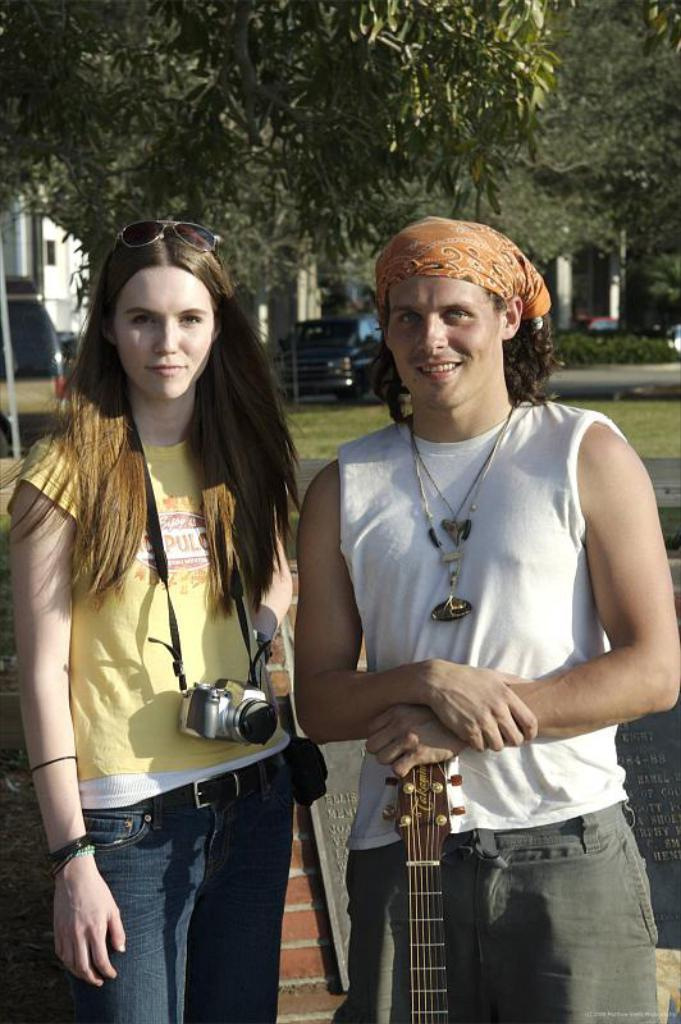What is the person on the right side of the image doing? The person is standing on the right side of the image and placing his hands on a guitar. What is the woman on the left side of the image holding? The woman is carrying a camera on the left side of the image. What can be seen in the background of the image? There are trees in the background of the image. What type of oil can be seen dripping from the guitar in the image? There is no oil present in the image, and the guitar is not depicted as dripping anything. 